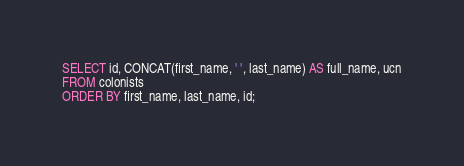<code> <loc_0><loc_0><loc_500><loc_500><_SQL_>SELECT id, CONCAT(first_name, ' ', last_name) AS full_name, ucn
FROM colonists
ORDER BY first_name, last_name, id;</code> 